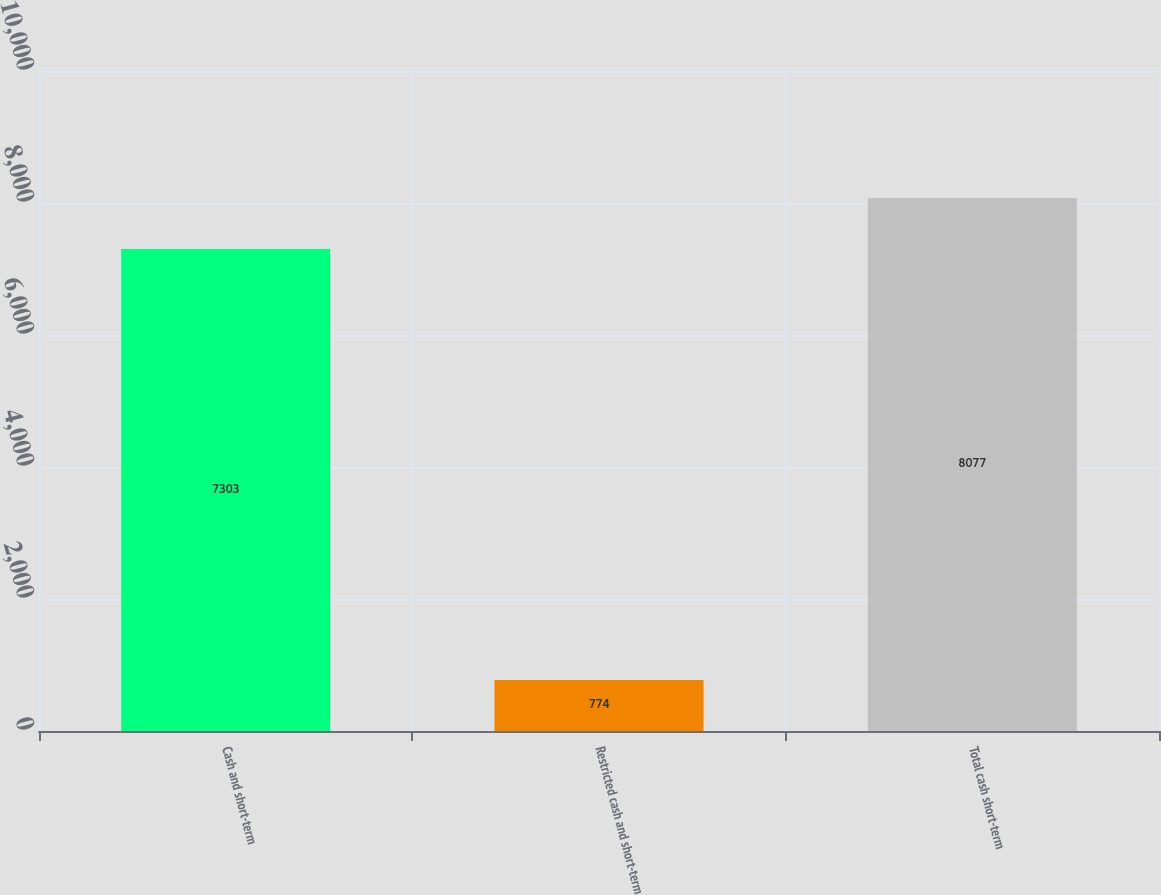Convert chart. <chart><loc_0><loc_0><loc_500><loc_500><bar_chart><fcel>Cash and short-term<fcel>Restricted cash and short-term<fcel>Total cash short-term<nl><fcel>7303<fcel>774<fcel>8077<nl></chart> 